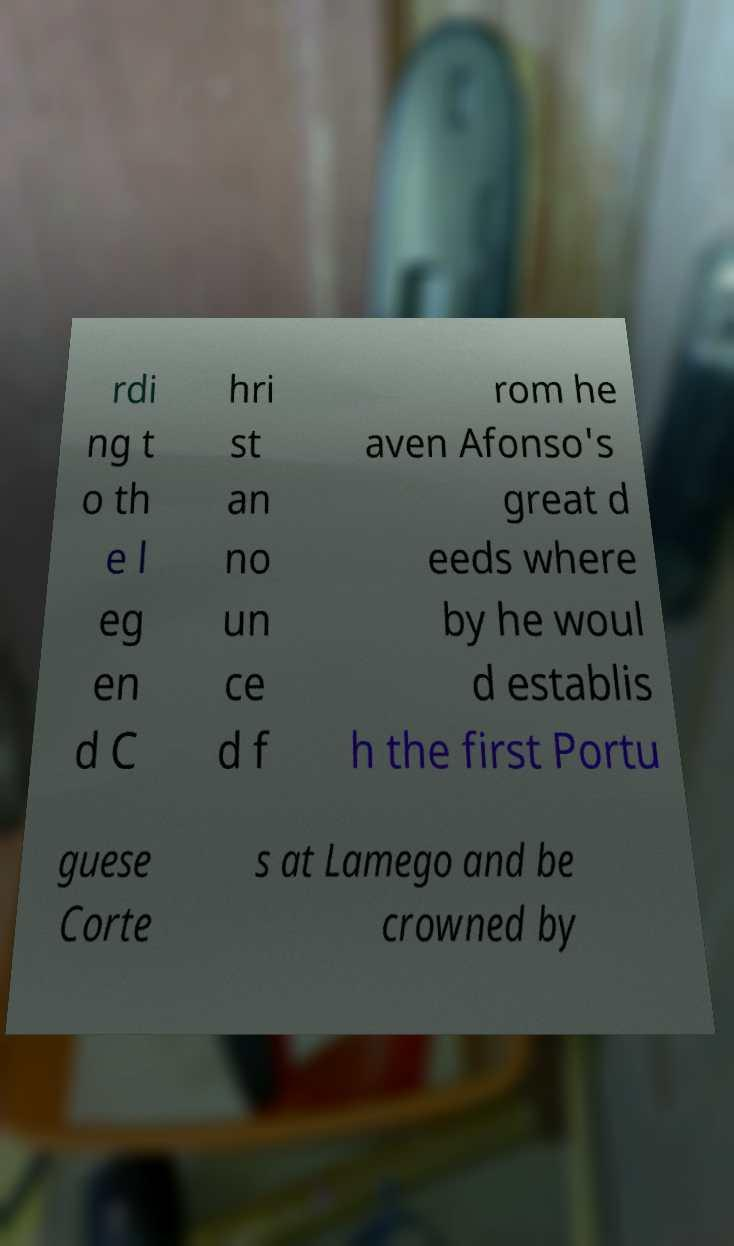Please identify and transcribe the text found in this image. rdi ng t o th e l eg en d C hri st an no un ce d f rom he aven Afonso's great d eeds where by he woul d establis h the first Portu guese Corte s at Lamego and be crowned by 